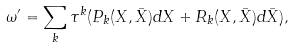Convert formula to latex. <formula><loc_0><loc_0><loc_500><loc_500>\omega ^ { \prime } = \sum _ { k } \tau ^ { k } ( P _ { k } ( X , \bar { X } ) d X + R _ { k } ( X , \bar { X } ) d \bar { X } ) ,</formula> 